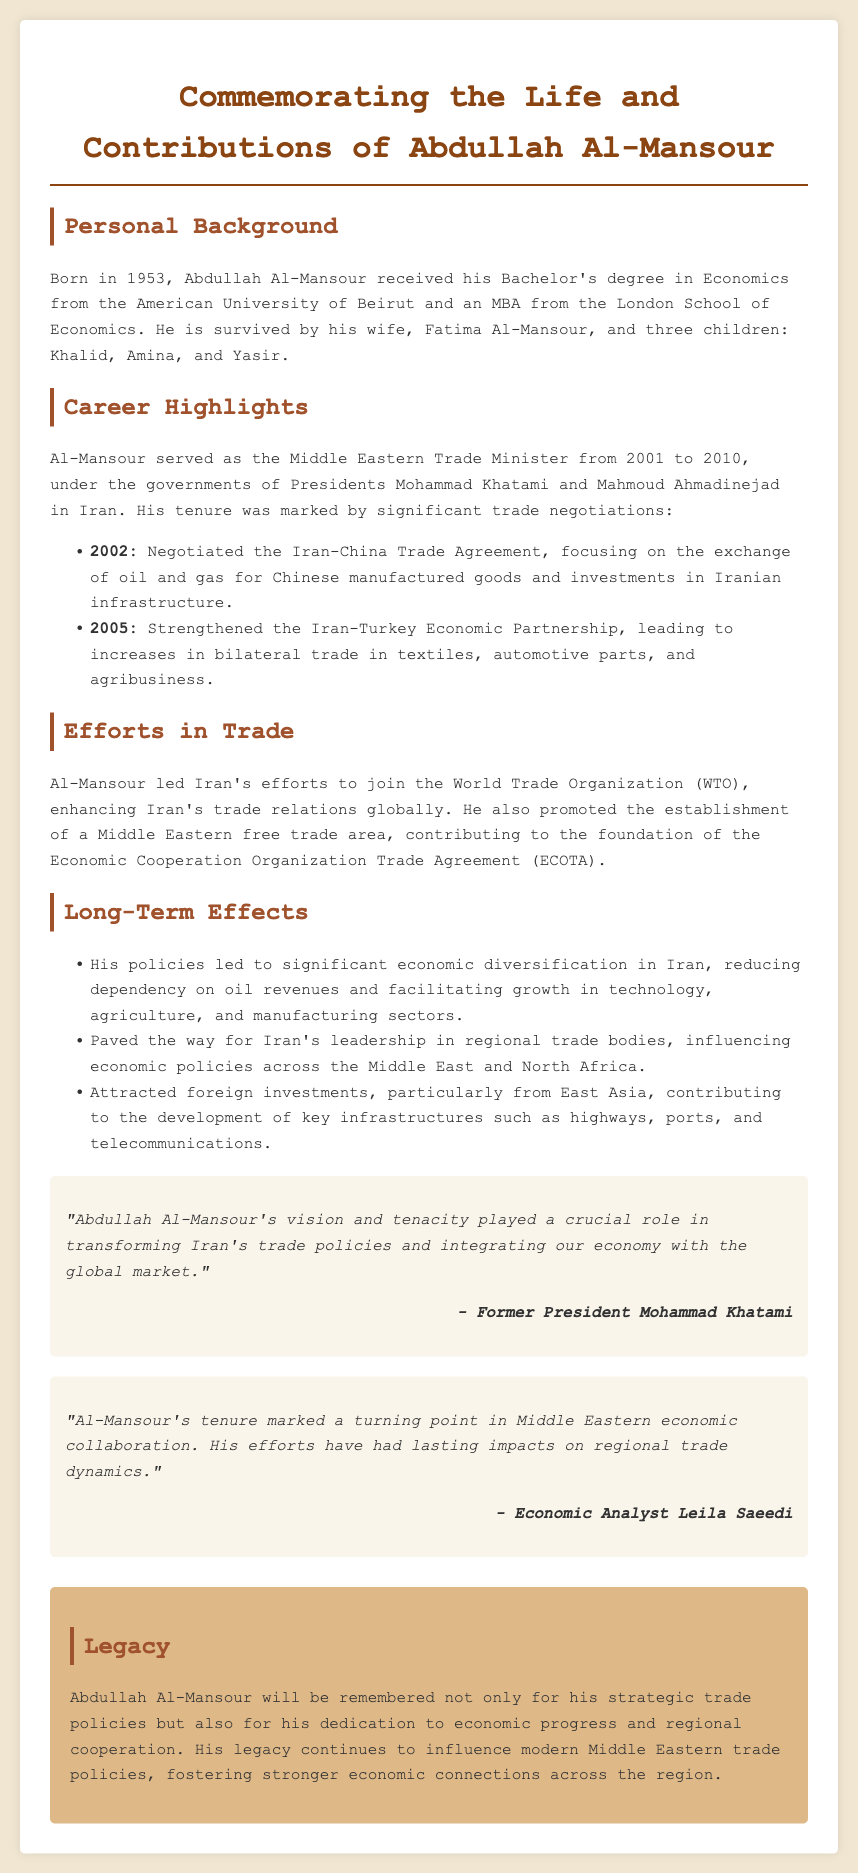What years did Abdullah Al-Mansour serve as the Trade Minister? The document states that Abdullah Al-Mansour served as the Middle Eastern Trade Minister from 2001 to 2010.
Answer: 2001 to 2010 What agreement did Al-Mansour negotiate in 2002? The document mentions that he negotiated the Iran-China Trade Agreement in 2002.
Answer: Iran-China Trade Agreement Which two countries were involved in the 2005 Economic Partnership? The text specifically refers to the Iran-Turkey Economic Partnership established in 2005.
Answer: Iran and Turkey What major organization did Al-Mansour lead efforts to join? The document states that he led Iran's efforts to join the World Trade Organization (WTO).
Answer: World Trade Organization (WTO) What long-term economic effect did Al-Mansour's policies promote? The text highlights significant economic diversification in Iran as a long-term effect of his policies.
Answer: Economic diversification Who is quoted stating that Al-Mansour had a crucial role in transforming Iran's trade policies? The document credits Former President Mohammad Khatami with this statement about Al-Mansour.
Answer: Mohammad Khatami What is one of the key infrastructure developments attracted by foreign investments during Al-Mansour's tenure? The document lists highways, ports, and telecommunications as key infrastructure developments.
Answer: Highways What type of free trade area did Al-Mansour promote? The text mentions his contribution to the establishment of a Middle Eastern free trade area.
Answer: Middle Eastern free trade area What will Abdullah Al-Mansour be remembered for? The document states that he will be remembered for his strategic trade policies and dedication to economic progress.
Answer: Strategic trade policies and dedication to economic progress 